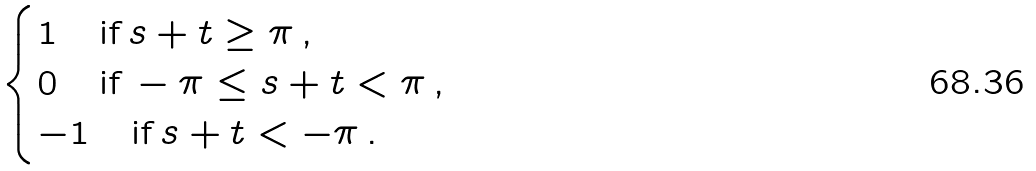<formula> <loc_0><loc_0><loc_500><loc_500>\begin{cases} 1 \quad \text {if} \, s + t \geq \pi \, , \\ 0 \quad \text {if} \, - \pi \leq s + t < \pi \, , \\ - 1 \quad \text {if} \, s + t < - \pi \, . \end{cases}</formula> 